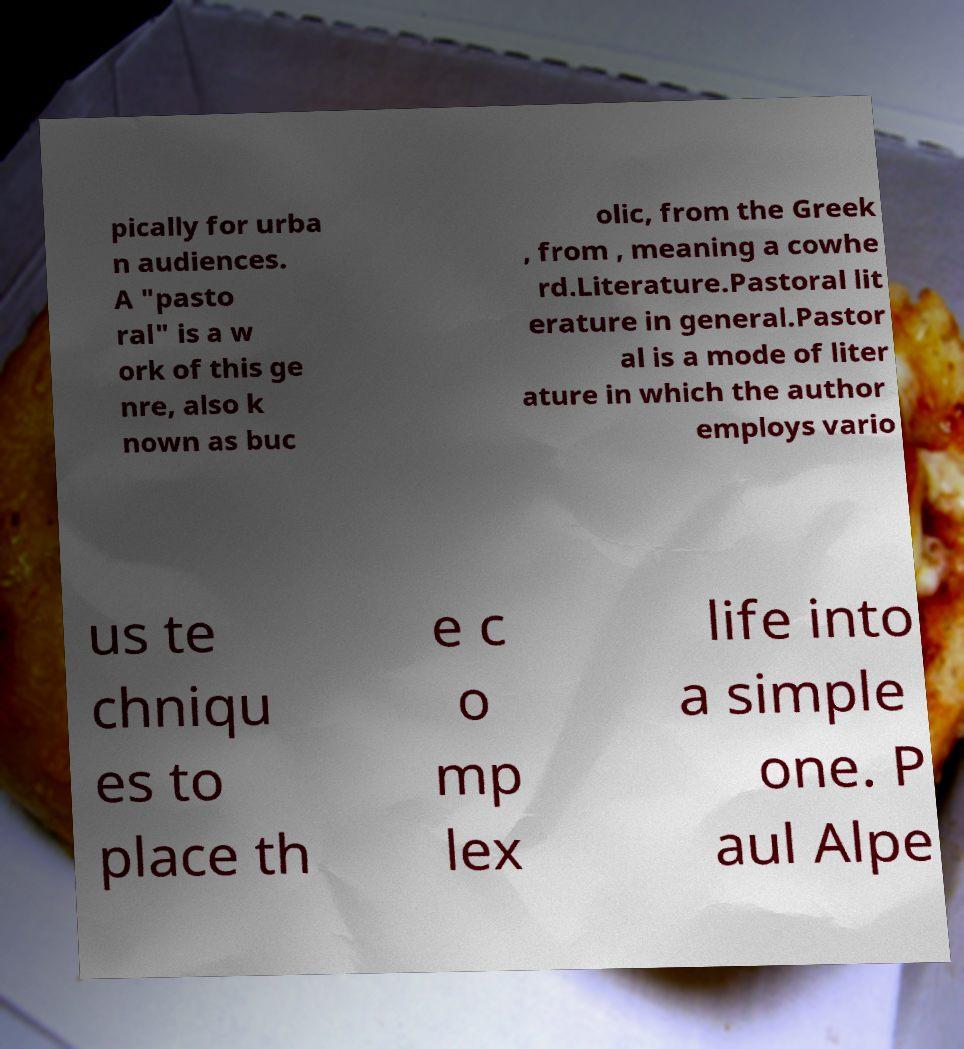Please read and relay the text visible in this image. What does it say? pically for urba n audiences. A "pasto ral" is a w ork of this ge nre, also k nown as buc olic, from the Greek , from , meaning a cowhe rd.Literature.Pastoral lit erature in general.Pastor al is a mode of liter ature in which the author employs vario us te chniqu es to place th e c o mp lex life into a simple one. P aul Alpe 